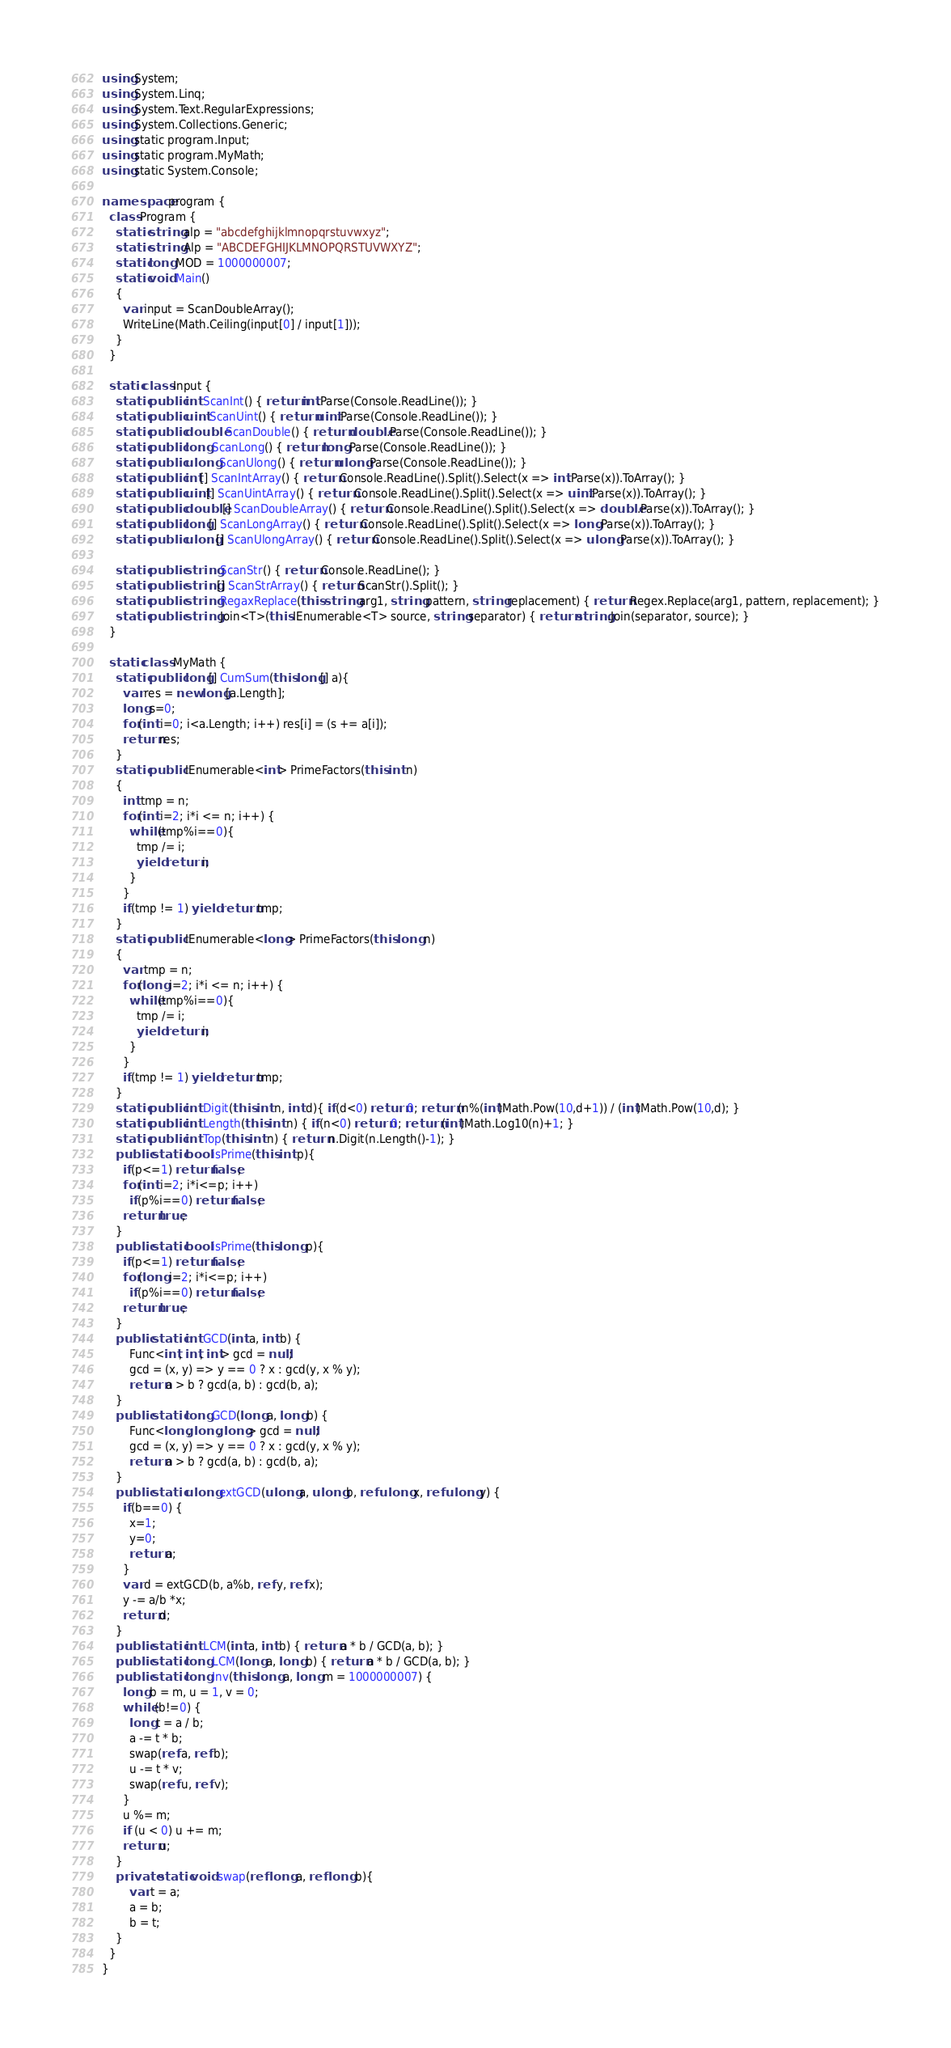<code> <loc_0><loc_0><loc_500><loc_500><_C#_>using System;
using System.Linq;
using System.Text.RegularExpressions;
using System.Collections.Generic;
using static program.Input;
using static program.MyMath;
using static System.Console;

namespace program {
  class Program {
    static string alp = "abcdefghijklmnopqrstuvwxyz";
    static string Alp = "ABCDEFGHIJKLMNOPQRSTUVWXYZ";
    static long MOD = 1000000007;
    static void Main()
    {
      var input = ScanDoubleArray();
      WriteLine(Math.Ceiling(input[0] / input[1]));
    }
  }
  
  static class Input {
    static public int ScanInt() { return int.Parse(Console.ReadLine()); }
    static public uint ScanUint() { return uint.Parse(Console.ReadLine()); }
    static public double ScanDouble() { return double.Parse(Console.ReadLine()); }
    static public long ScanLong() { return long.Parse(Console.ReadLine()); }
    static public ulong ScanUlong() { return ulong.Parse(Console.ReadLine()); }
    static public int[] ScanIntArray() { return Console.ReadLine().Split().Select(x => int.Parse(x)).ToArray(); }
    static public uint[] ScanUintArray() { return Console.ReadLine().Split().Select(x => uint.Parse(x)).ToArray(); }
    static public double[] ScanDoubleArray() { return Console.ReadLine().Split().Select(x => double.Parse(x)).ToArray(); }
    static public long[] ScanLongArray() { return Console.ReadLine().Split().Select(x => long.Parse(x)).ToArray(); }
    static public ulong[] ScanUlongArray() { return Console.ReadLine().Split().Select(x => ulong.Parse(x)).ToArray(); }

    static public string ScanStr() { return Console.ReadLine(); }
    static public string[] ScanStrArray() { return ScanStr().Split(); }
    static public string RegaxReplace(this string arg1, string pattern, string replacement) { return Regex.Replace(arg1, pattern, replacement); }
    static public string Join<T>(this IEnumerable<T> source, string separator) { return string.Join(separator, source); }
  }
  
  static class MyMath {
    static public long[] CumSum(this long[] a){
      var res = new long[a.Length];
      long s=0;
      for(int i=0; i<a.Length; i++) res[i] = (s += a[i]);
      return res;
    }
    static public IEnumerable<int> PrimeFactors(this int n)
    {
      int tmp = n;
      for(int i=2; i*i <= n; i++) {
        while(tmp%i==0){
          tmp /= i;
          yield return i;
        }
      }
      if(tmp != 1) yield return tmp;
    }
    static public IEnumerable<long> PrimeFactors(this long n)
    {
      var tmp = n;
      for(long i=2; i*i <= n; i++) {
        while(tmp%i==0){
          tmp /= i;
          yield return i;
        }
      }
      if(tmp != 1) yield return tmp;
    }
    static public int Digit(this int n, int d){ if(d<0) return 0; return (n%(int)Math.Pow(10,d+1)) / (int)Math.Pow(10,d); }
  	static public int Length(this int n) { if(n<0) return 0; return (int)Math.Log10(n)+1; }
    static public int Top(this int n) { return n.Digit(n.Length()-1); }
    public static bool isPrime(this int p){
      if(p<=1) return false;
      for(int i=2; i*i<=p; i++)
        if(p%i==0) return false;
      return true;
    }
    public static bool isPrime(this long p){
      if(p<=1) return false;
      for(long i=2; i*i<=p; i++)
        if(p%i==0) return false;
      return true;
    }
    public static int GCD(int a, int b) {
        Func<int, int, int> gcd = null;
        gcd = (x, y) => y == 0 ? x : gcd(y, x % y);
        return a > b ? gcd(a, b) : gcd(b, a);
    }
    public static long GCD(long a, long b) {
        Func<long, long, long> gcd = null;
        gcd = (x, y) => y == 0 ? x : gcd(y, x % y);
        return a > b ? gcd(a, b) : gcd(b, a);
    }
    public static ulong extGCD(ulong a, ulong b, ref ulong x, ref ulong y) {
      if(b==0) {
        x=1; 
        y=0;
        return a;
      }
      var d = extGCD(b, a%b, ref y, ref x);
      y -= a/b *x;
      return d;
    }
    public static int LCM(int a, int b) { return a * b / GCD(a, b); }
    public static long LCM(long a, long b) { return a * b / GCD(a, b); }
    public static long Inv(this long a, long m = 1000000007) {
      long b = m, u = 1, v = 0;
      while (b!=0) {
        long t = a / b;
        a -= t * b;
        swap(ref a, ref b);
        u -= t * v;
        swap(ref u, ref v);
      }
      u %= m; 
      if (u < 0) u += m;
      return u;
	}
    private static void swap(ref long a, ref long b){
        var t = a;
        a = b;
        b = t;
    }
  }
}
</code> 